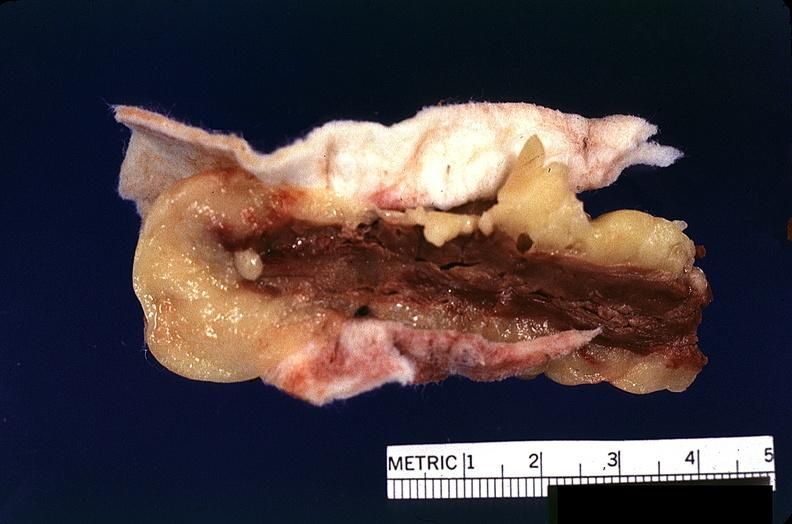what is present?
Answer the question using a single word or phrase. Cardiovascular 